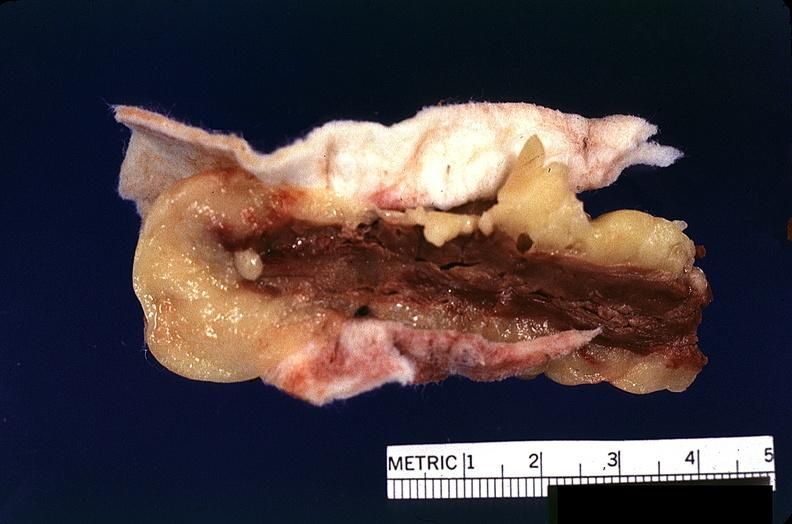what is present?
Answer the question using a single word or phrase. Cardiovascular 